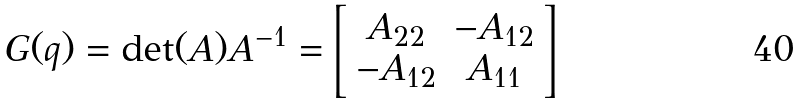Convert formula to latex. <formula><loc_0><loc_0><loc_500><loc_500>G ( q ) = \det ( A ) A ^ { - 1 } = \left [ \begin{array} { c c } A _ { 2 2 } & - A _ { 1 2 } \\ - A _ { 1 2 } & A _ { 1 1 } \end{array} \right ]</formula> 